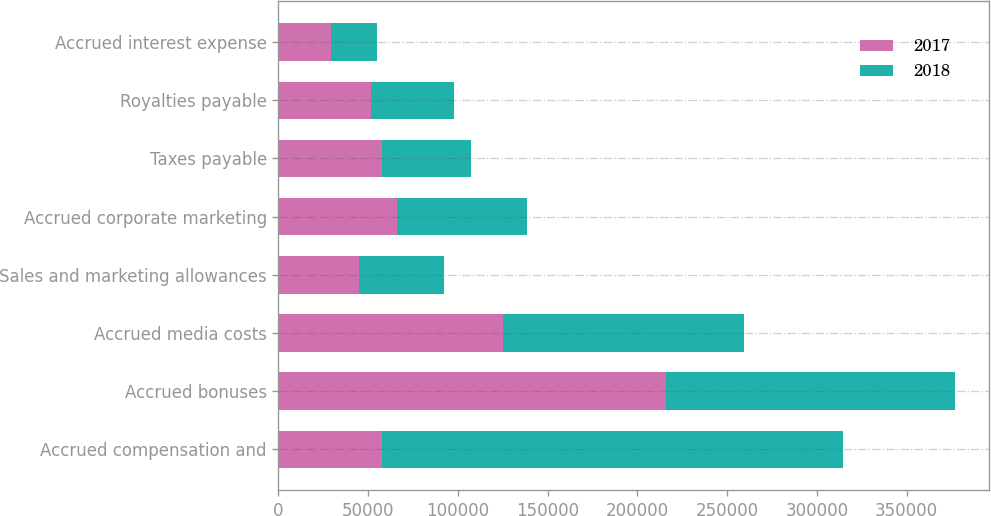Convert chart. <chart><loc_0><loc_0><loc_500><loc_500><stacked_bar_chart><ecel><fcel>Accrued compensation and<fcel>Accrued bonuses<fcel>Accrued media costs<fcel>Sales and marketing allowances<fcel>Accrued corporate marketing<fcel>Taxes payable<fcel>Royalties payable<fcel>Accrued interest expense<nl><fcel>2017<fcel>57525<fcel>216007<fcel>124849<fcel>44968<fcel>66186<fcel>57525<fcel>51529<fcel>29481<nl><fcel>2018<fcel>256862<fcel>160880<fcel>134525<fcel>47389<fcel>72087<fcel>49550<fcel>46411<fcel>25594<nl></chart> 